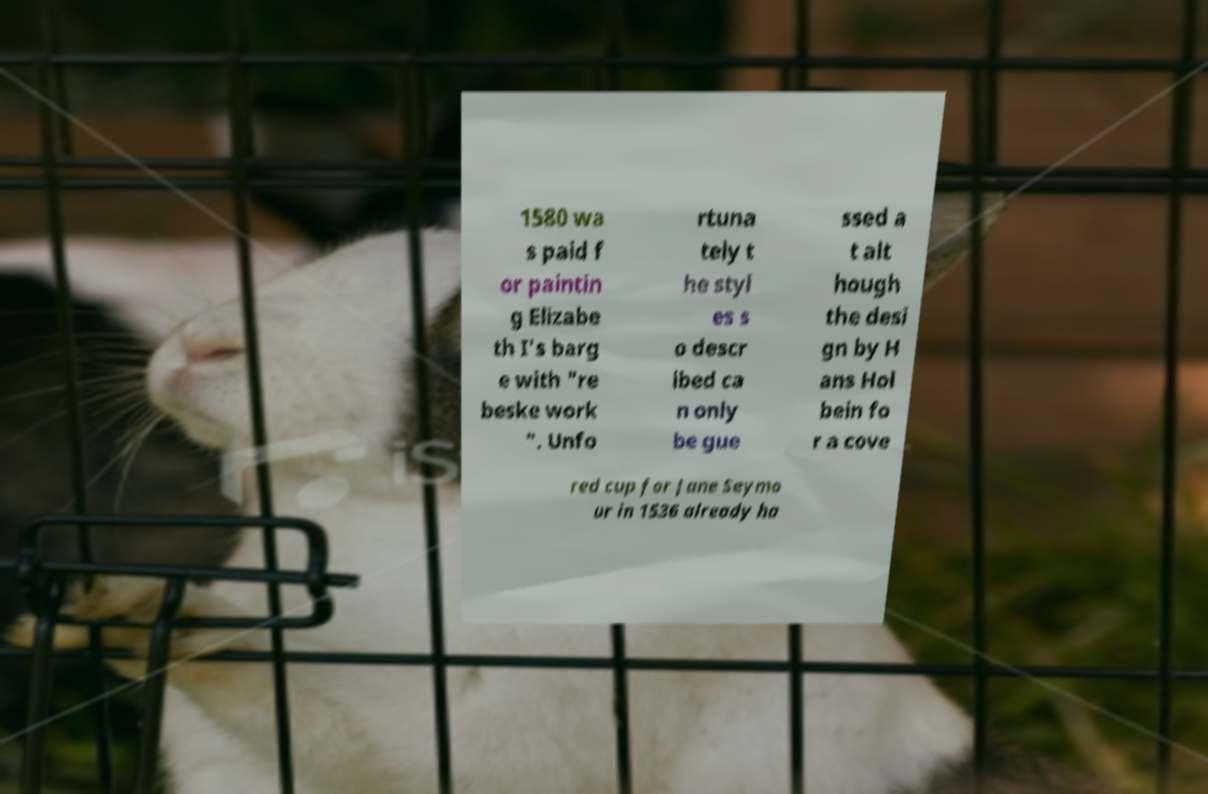Please read and relay the text visible in this image. What does it say? 1580 wa s paid f or paintin g Elizabe th I's barg e with "re beske work ". Unfo rtuna tely t he styl es s o descr ibed ca n only be gue ssed a t alt hough the desi gn by H ans Hol bein fo r a cove red cup for Jane Seymo ur in 1536 already ha 